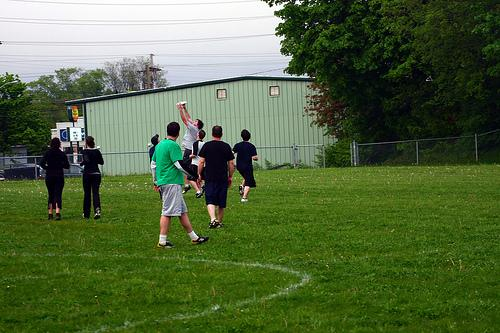Provide a detailed description of the image as a whole. The image features a group of people engaging in various activities, such as catching a frisbee or talking, in a field surrounded by trees and buildings. There are several objects within the scene, including a sign and powerlines. List the primary actions taken by the people in the image. catching the frisbee, talking, jumping, hanging out, running Determine any challenges that may be present when reasoning about the various objects' positions in the image. As some objects are overlapping or close together, it may be difficult to assess whether one is in front of or behind another. Which objects are interacting with people in this image? Frisbee, field, fence, and the sign. How many objects, such as trees and buildings, are featured in the image? Two trees, three buildings, and two windows. What objects are predominant outside of the field area? Buildings, trees, powerlines, and a fence. Count the people that are hanging out in the field. At least 10 people in various groups. What is happening regarding the frisbee in the image? A man is catching the frisbee while jumping in the air. Identify the sentiment conveyed by the image. The image conveys a joyful and active atmosphere. Rate the quality of the image from 1 to 10, with 1 being the lowest and 10 being the highest. 6 